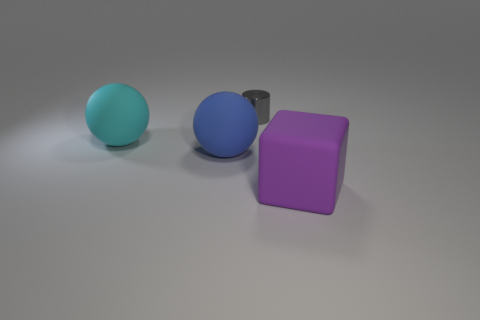Subtract all cyan balls. How many balls are left? 1 Subtract 1 cubes. How many cubes are left? 0 Add 3 tiny balls. How many objects exist? 7 Subtract all cylinders. How many objects are left? 3 Add 3 big blue spheres. How many big blue spheres exist? 4 Subtract 0 red balls. How many objects are left? 4 Subtract all tiny green metal balls. Subtract all large rubber spheres. How many objects are left? 2 Add 3 purple blocks. How many purple blocks are left? 4 